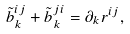Convert formula to latex. <formula><loc_0><loc_0><loc_500><loc_500>\tilde { b } ^ { i j } _ { k } + \tilde { b } ^ { j i } _ { k } = \partial _ { k } r ^ { i j } ,</formula> 